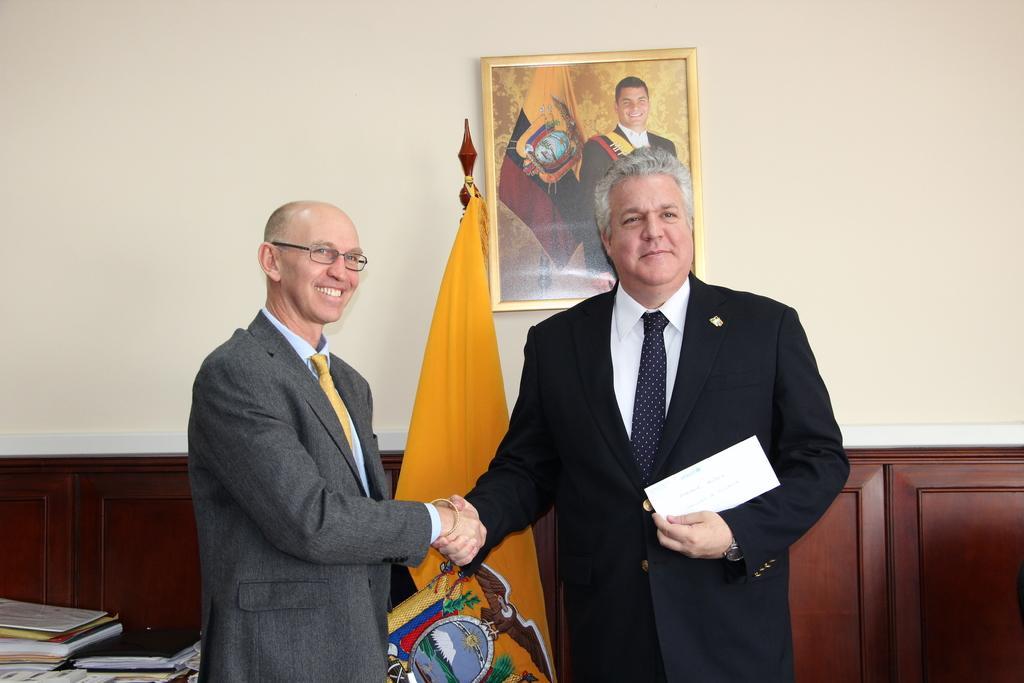Describe this image in one or two sentences. In this picture I can see couple of men standing and shaking their hands and I can see few books on the table. I can see a flag and a photo frame in the back and I can see a man holding a paper in his hand. 